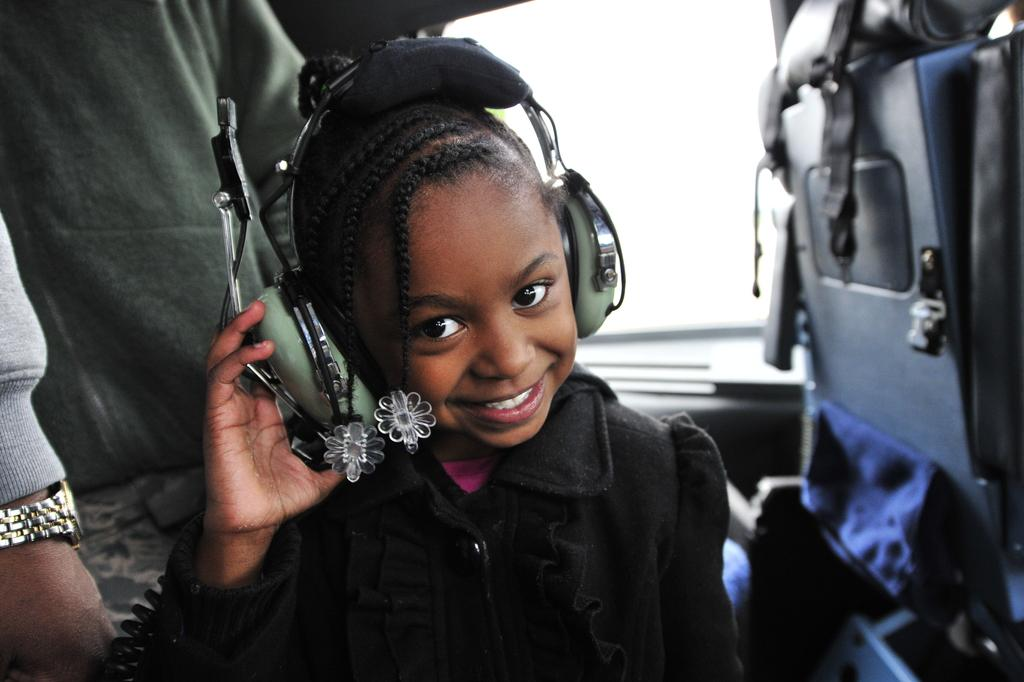How many people are in the image? There are two persons in the image. What object can be seen in the image that is typically used for sitting? There is a chair in the image. What type of audio accessory is visible in the image? A headphone is visible in the image. Can you describe the setting of the image? The image may have been taken in a vehicle, and there is a window present. What time of day might the image have been taken? The image may have been taken during the day. What type of vase is being used to cook in the image? There is no vase or cooking activity present in the image. How many knots can be seen in the image? There are no knots visible in the image. 